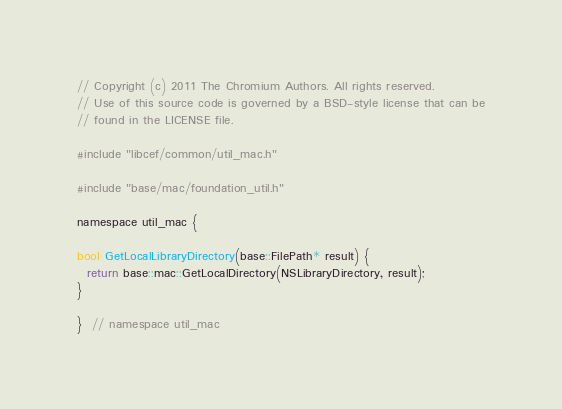<code> <loc_0><loc_0><loc_500><loc_500><_ObjectiveC_>// Copyright (c) 2011 The Chromium Authors. All rights reserved.
// Use of this source code is governed by a BSD-style license that can be
// found in the LICENSE file.

#include "libcef/common/util_mac.h"

#include "base/mac/foundation_util.h"

namespace util_mac {

bool GetLocalLibraryDirectory(base::FilePath* result) {
  return base::mac::GetLocalDirectory(NSLibraryDirectory, result);
}

}  // namespace util_mac
</code> 